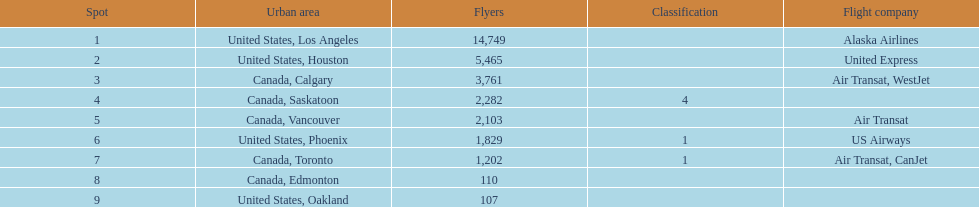How many more passengers flew to los angeles than to saskatoon from manzanillo airport in 2013? 12,467. 